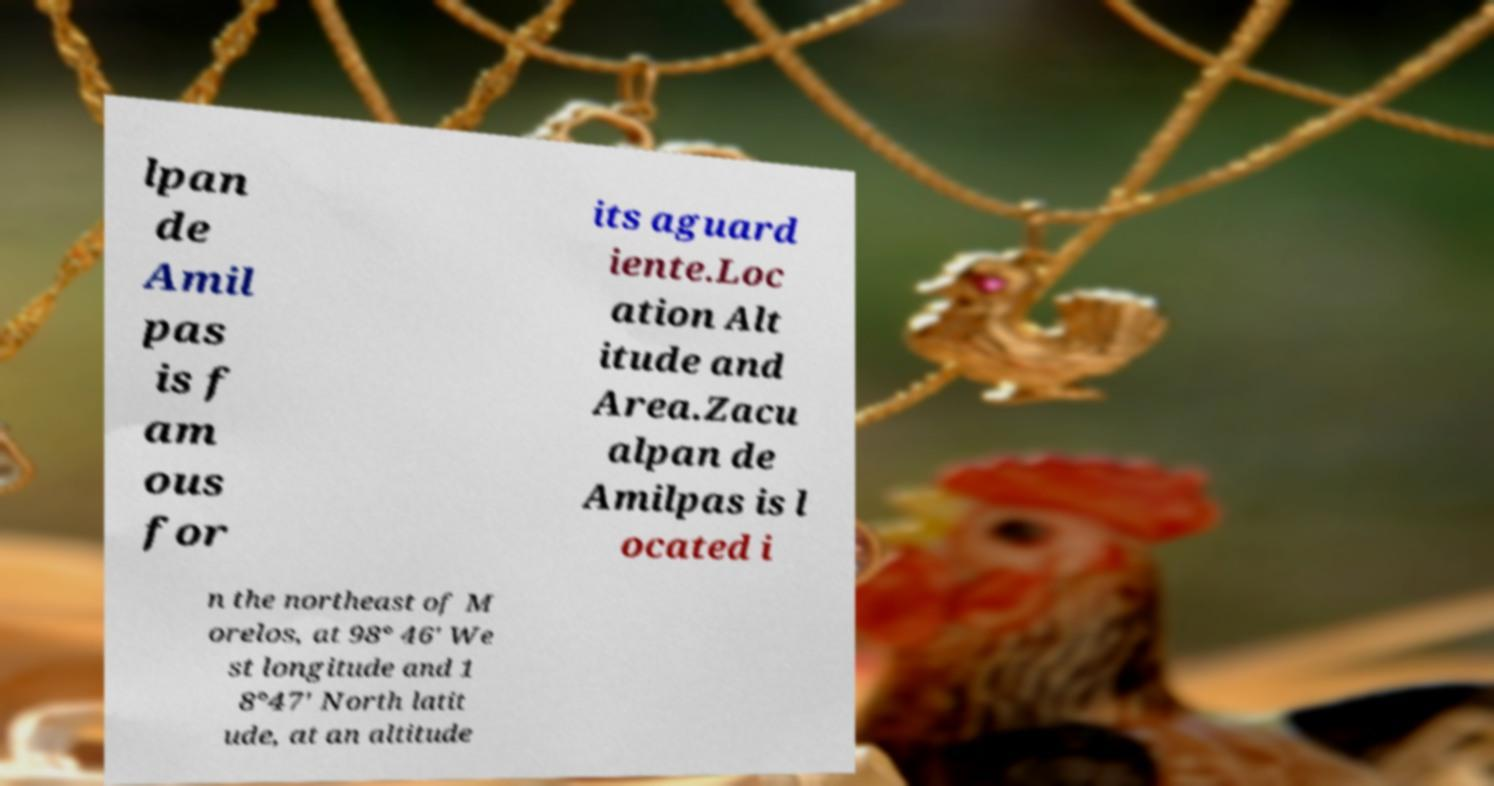Can you read and provide the text displayed in the image?This photo seems to have some interesting text. Can you extract and type it out for me? lpan de Amil pas is f am ous for its aguard iente.Loc ation Alt itude and Area.Zacu alpan de Amilpas is l ocated i n the northeast of M orelos, at 98° 46' We st longitude and 1 8°47' North latit ude, at an altitude 